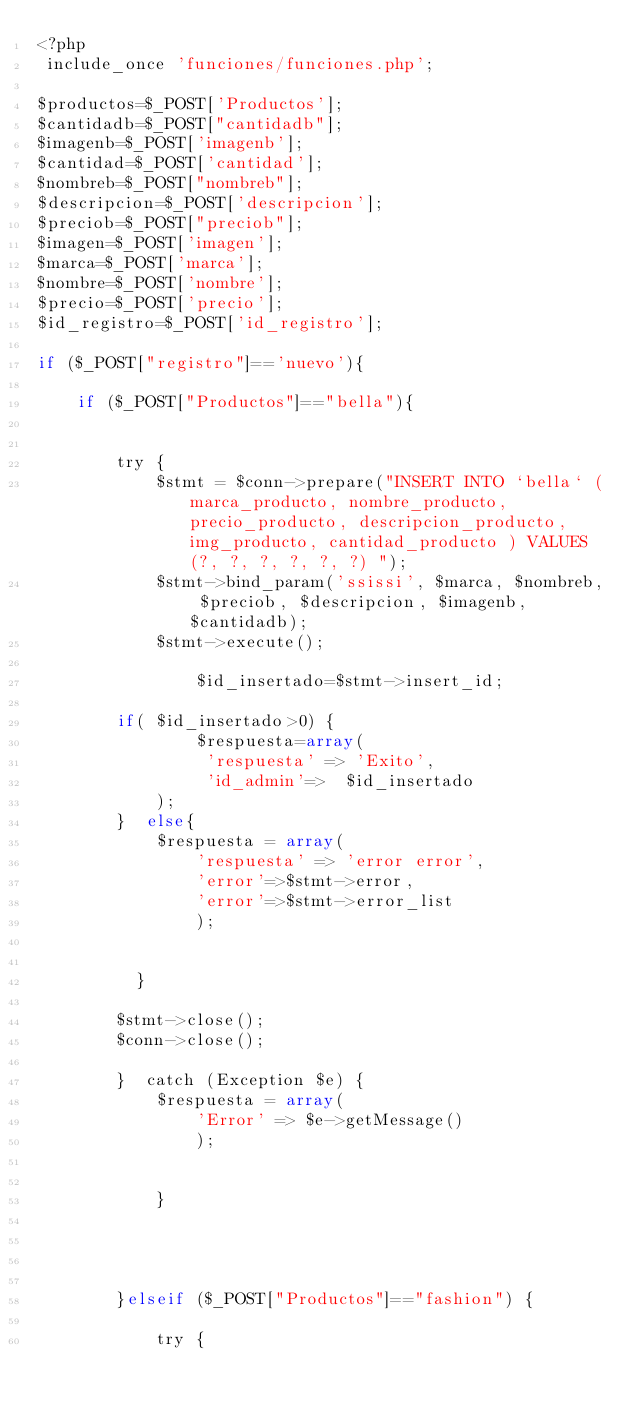Convert code to text. <code><loc_0><loc_0><loc_500><loc_500><_PHP_><?php
 include_once 'funciones/funciones.php';

$productos=$_POST['Productos'];
$cantidadb=$_POST["cantidadb"];
$imagenb=$_POST['imagenb'];
$cantidad=$_POST['cantidad'];
$nombreb=$_POST["nombreb"];
$descripcion=$_POST['descripcion'];
$preciob=$_POST["preciob"];
$imagen=$_POST['imagen'];
$marca=$_POST['marca'];
$nombre=$_POST['nombre'];
$precio=$_POST['precio'];
$id_registro=$_POST['id_registro'];

if ($_POST["registro"]=='nuevo'){

    if ($_POST["Productos"]=="bella"){ 
   

        try {
            $stmt = $conn->prepare("INSERT INTO `bella` (marca_producto, nombre_producto,  precio_producto, descripcion_producto, img_producto, cantidad_producto ) VALUES(?, ?, ?, ?, ?, ?) ");
            $stmt->bind_param('ssissi', $marca, $nombreb, $preciob, $descripcion, $imagenb, $cantidadb);
            $stmt->execute();

                $id_insertado=$stmt->insert_id;

        if( $id_insertado>0) {
                $respuesta=array(
                 'respuesta' => 'Exito',
                 'id_admin'=>  $id_insertado
            );    
        }  else{
            $respuesta = array(
                'respuesta' => 'error error',
                'error'=>$stmt->error,
                'error'=>$stmt->error_list
                );
         
        
          }
                
        $stmt->close();
        $conn->close();

        }  catch (Exception $e) {
            $respuesta = array(
                'Error' => $e->getMessage()
                );
        

            }

             


        }elseif ($_POST["Productos"]=="fashion") {

            try {</code> 